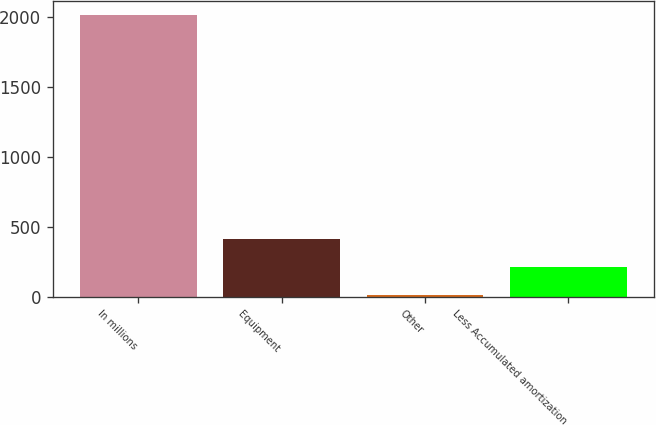Convert chart. <chart><loc_0><loc_0><loc_500><loc_500><bar_chart><fcel>In millions<fcel>Equipment<fcel>Other<fcel>Less Accumulated amortization<nl><fcel>2012<fcel>414.4<fcel>15<fcel>214.7<nl></chart> 